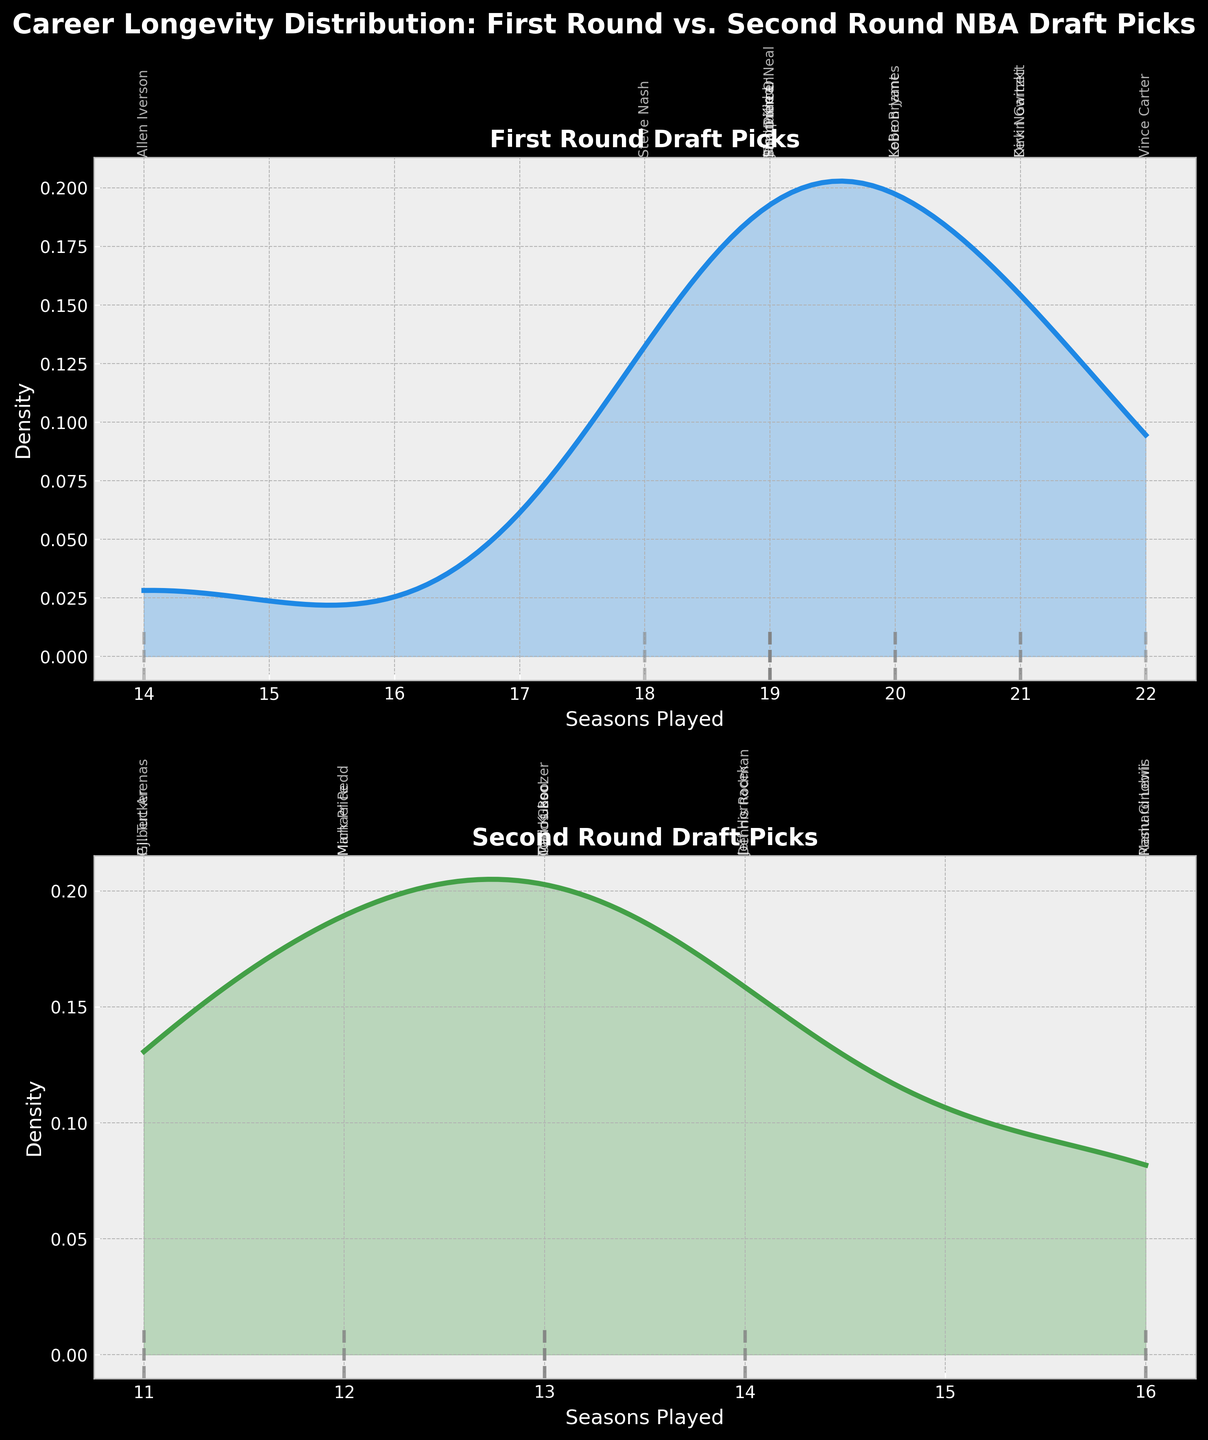What is the title of the figure? The title of the figure is displayed at the top and describes the content it represents. By reading the top-center portion of the figure, you can see the title, which is "Career Longevity Distribution: First Round vs. Second Round NBA Draft Picks".
Answer: Career Longevity Distribution: First Round vs. Second Round NBA Draft Picks What are the labels of the x-axis and y-axis for the first subplot (First Round)? The labels on the x-axis and y-axis provide information on what is being measured along those axes. In the first subplot, labeled "First Round Draft Picks", the x-axis is labeled "Seasons Played", and the y-axis is labeled "Density".
Answer: Seasons Played, Density Which round shows a greater density of players with 20 or more seasons played? To determine which round has a greater density of players with 20 or more seasons played, observe the areas under the density curves in both subplots from 20 seasons onwards. The First Round subplot has a noticeable density peak and filled area beyond 20 seasons, while the Second Round subplot has no significant density in this range.
Answer: First Round Are there any players in the Second Round subplot who played more than 16 seasons? By examining the Second Round subplot and looking for any vertical lines (representing players) extending beyond 16 seasons, you will see that there are no lines beyond 16 seasons for the Second Round players.
Answer: No What is the most common career longevity for First Round players? The most common career longevity can be found by identifying the highest peak (mode) of the density plot for First Round players. In the First Round subplot, the peak appears around 19-20 seasons, indicating the most common career length in this group.
Answer: 19-20 seasons Compare the density curves of both subplots in terms of their spread. Which round shows a wider spread of career longevities? To compare the spread of the density curves, observe the range of x-values where the curves have significant density. The First Round density curve spreads from around 14 to 22 seasons, while the Second Round density curve is mostly concentrated from about 11 to 16 seasons. This indicates the First Round has a wider spread of career longevities.
Answer: First Round What is the career longevity of Vince Carter, and in which subplot is he included? To find Vince Carter's career longevity and identify his subplot, look for his name next to a vertical line in one of the subplots. Vince Carter is in the First Round subplot, and his career longevity is marked at 22 seasons.
Answer: 22 seasons, First Round Which subplot, First Round or Second Round, has more density peaks? Density peaks indicate common career longevity values. By examining both subplots, the First Round has a noticeable peak around 19-20 seasons, and the Second Round has a more spread out but lower peak around 14 seasons. Thus, the First Round has a more distinct peak.
Answer: First Round In the Second Round subplot, what is the approximate career longevity range where players’ densities are the highest? To find the range of highest densities in the Second Round subplot, identify the central peak of the density curve. The peak is around 13-14 seasons, suggesting the highest density range is approximately 11 to 16 seasons.
Answer: 11 to 16 seasons 